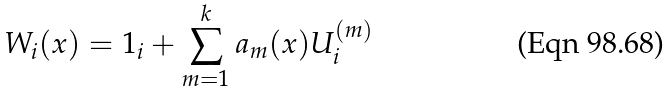Convert formula to latex. <formula><loc_0><loc_0><loc_500><loc_500>W _ { i } ( x ) = 1 _ { i } + \sum _ { m = 1 } ^ { k } a _ { m } ( x ) U _ { i } ^ { ( m ) }</formula> 